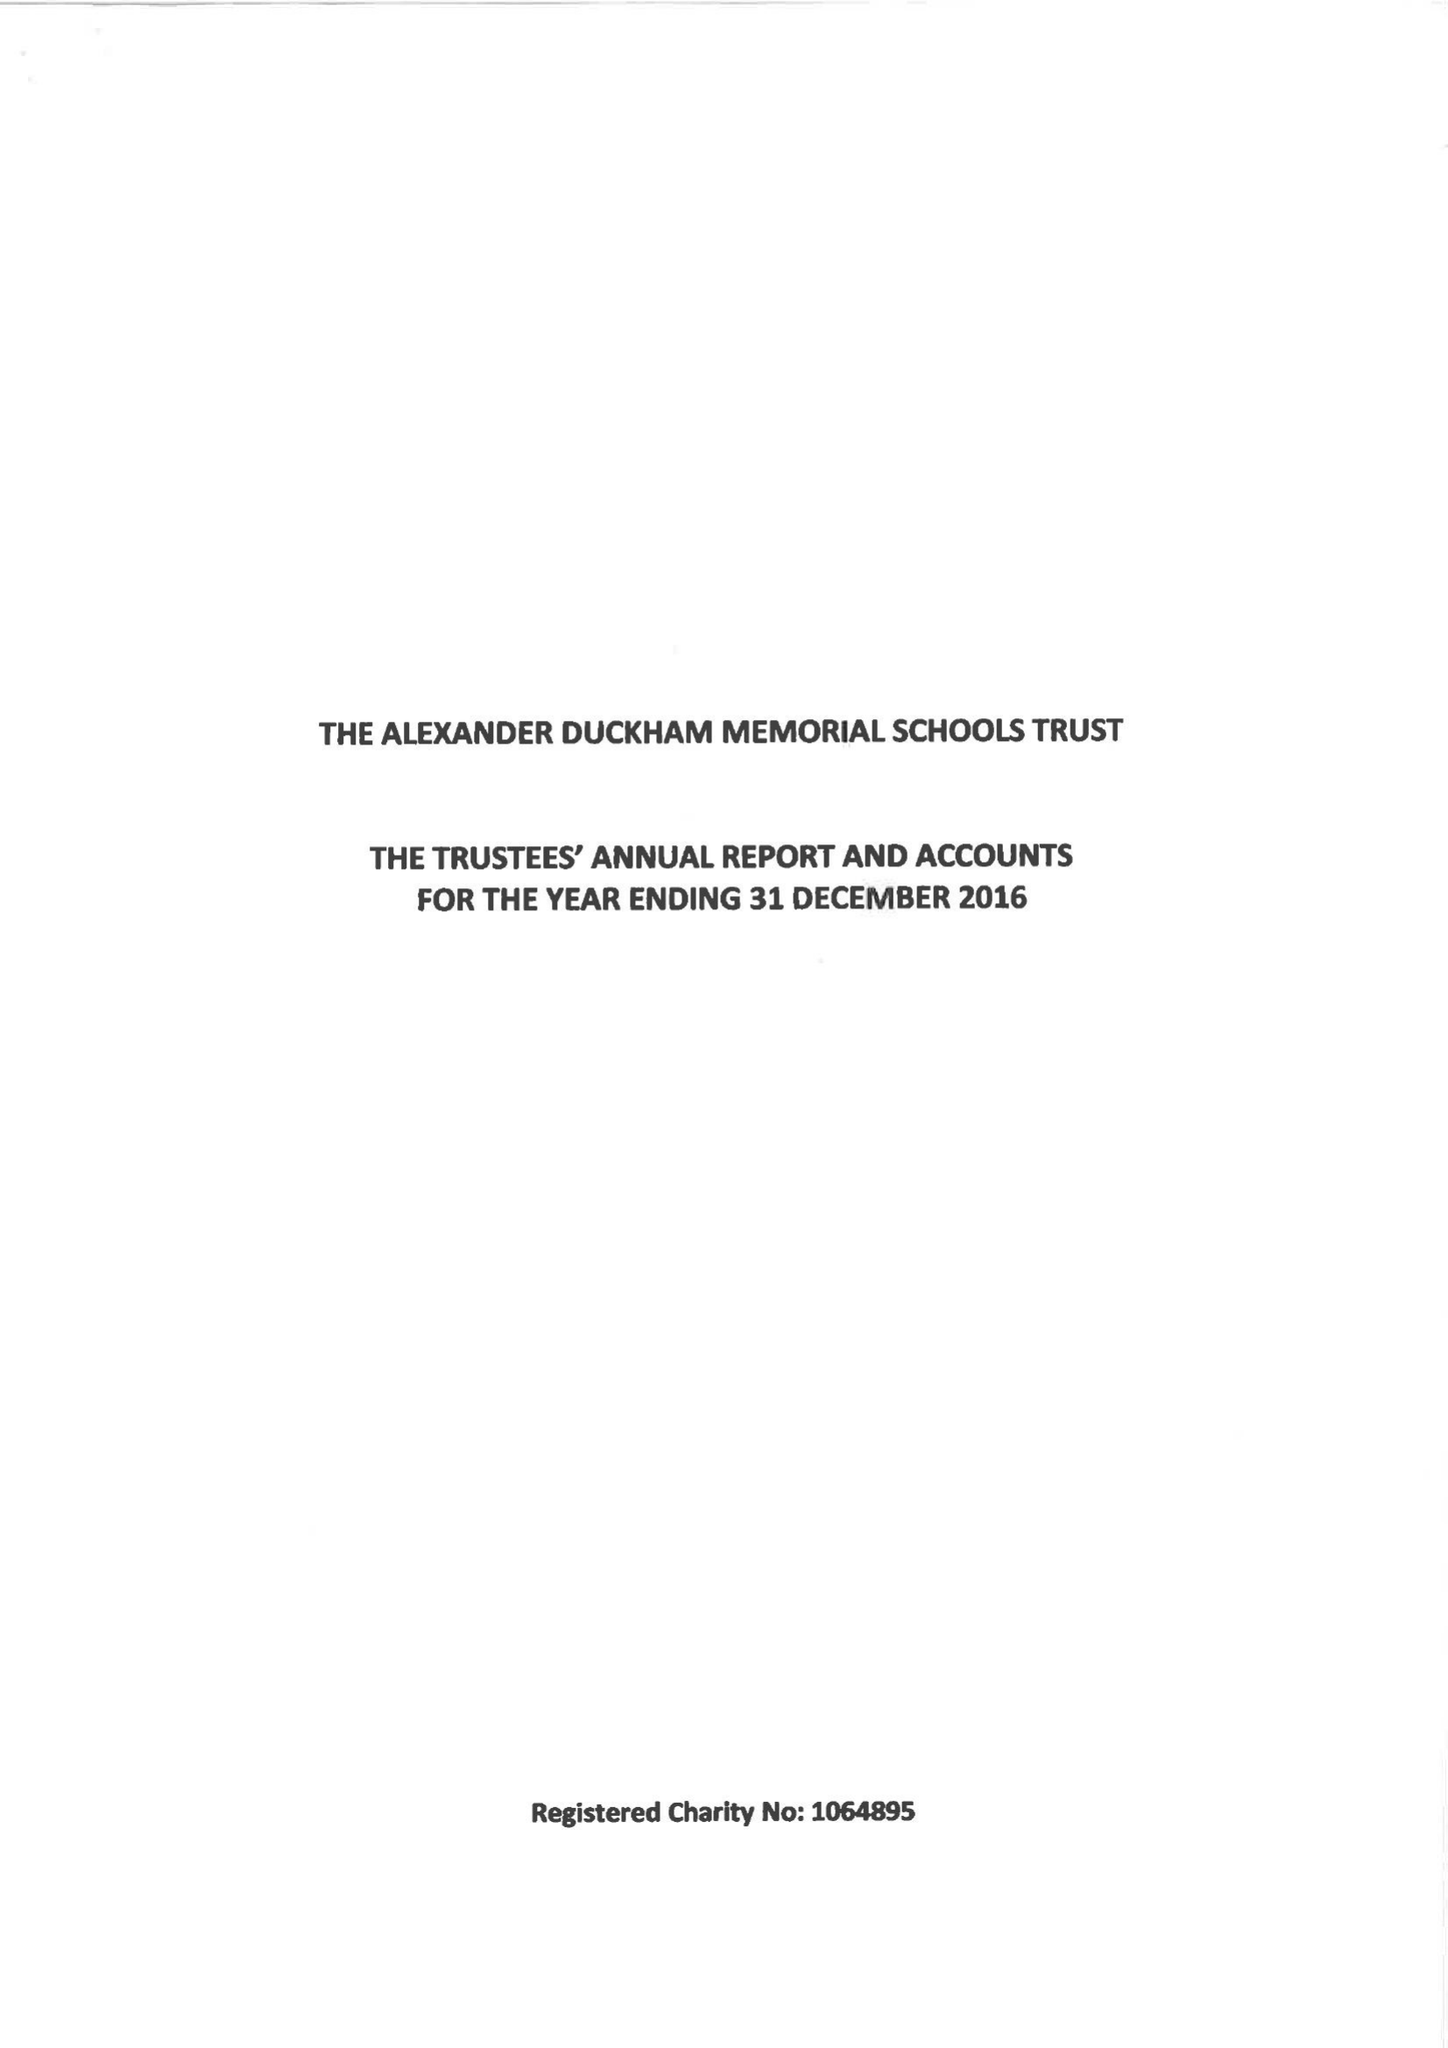What is the value for the report_date?
Answer the question using a single word or phrase. 2016-12-31 